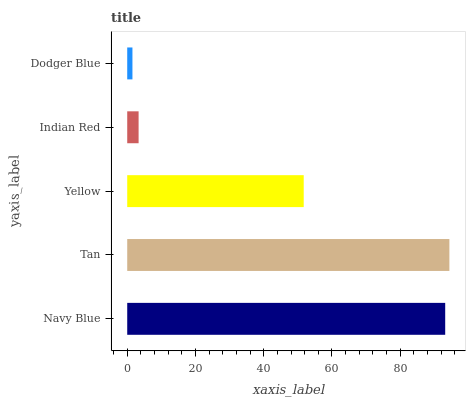Is Dodger Blue the minimum?
Answer yes or no. Yes. Is Tan the maximum?
Answer yes or no. Yes. Is Yellow the minimum?
Answer yes or no. No. Is Yellow the maximum?
Answer yes or no. No. Is Tan greater than Yellow?
Answer yes or no. Yes. Is Yellow less than Tan?
Answer yes or no. Yes. Is Yellow greater than Tan?
Answer yes or no. No. Is Tan less than Yellow?
Answer yes or no. No. Is Yellow the high median?
Answer yes or no. Yes. Is Yellow the low median?
Answer yes or no. Yes. Is Tan the high median?
Answer yes or no. No. Is Tan the low median?
Answer yes or no. No. 